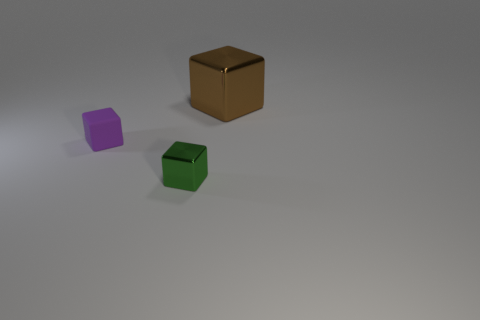Are there more tiny green shiny things than small brown metal cylinders?
Your answer should be compact. Yes. How many other objects are the same shape as the purple matte thing?
Your response must be concise. 2. What is the object that is to the left of the big brown cube and to the right of the matte cube made of?
Keep it short and to the point. Metal. The green block has what size?
Provide a short and direct response. Small. How many purple things are behind the small thing that is on the right side of the small thing behind the green metal object?
Your answer should be very brief. 1. What shape is the shiny thing behind the metallic block that is in front of the large brown metal block?
Keep it short and to the point. Cube. There is a green thing that is the same shape as the tiny purple rubber object; what size is it?
Provide a succinct answer. Small. Is there anything else that has the same size as the brown thing?
Your response must be concise. No. What color is the cube that is behind the small purple cube?
Your answer should be very brief. Brown. There is a block that is behind the thing on the left side of the metallic cube that is to the left of the large brown object; what is its material?
Offer a terse response. Metal. 